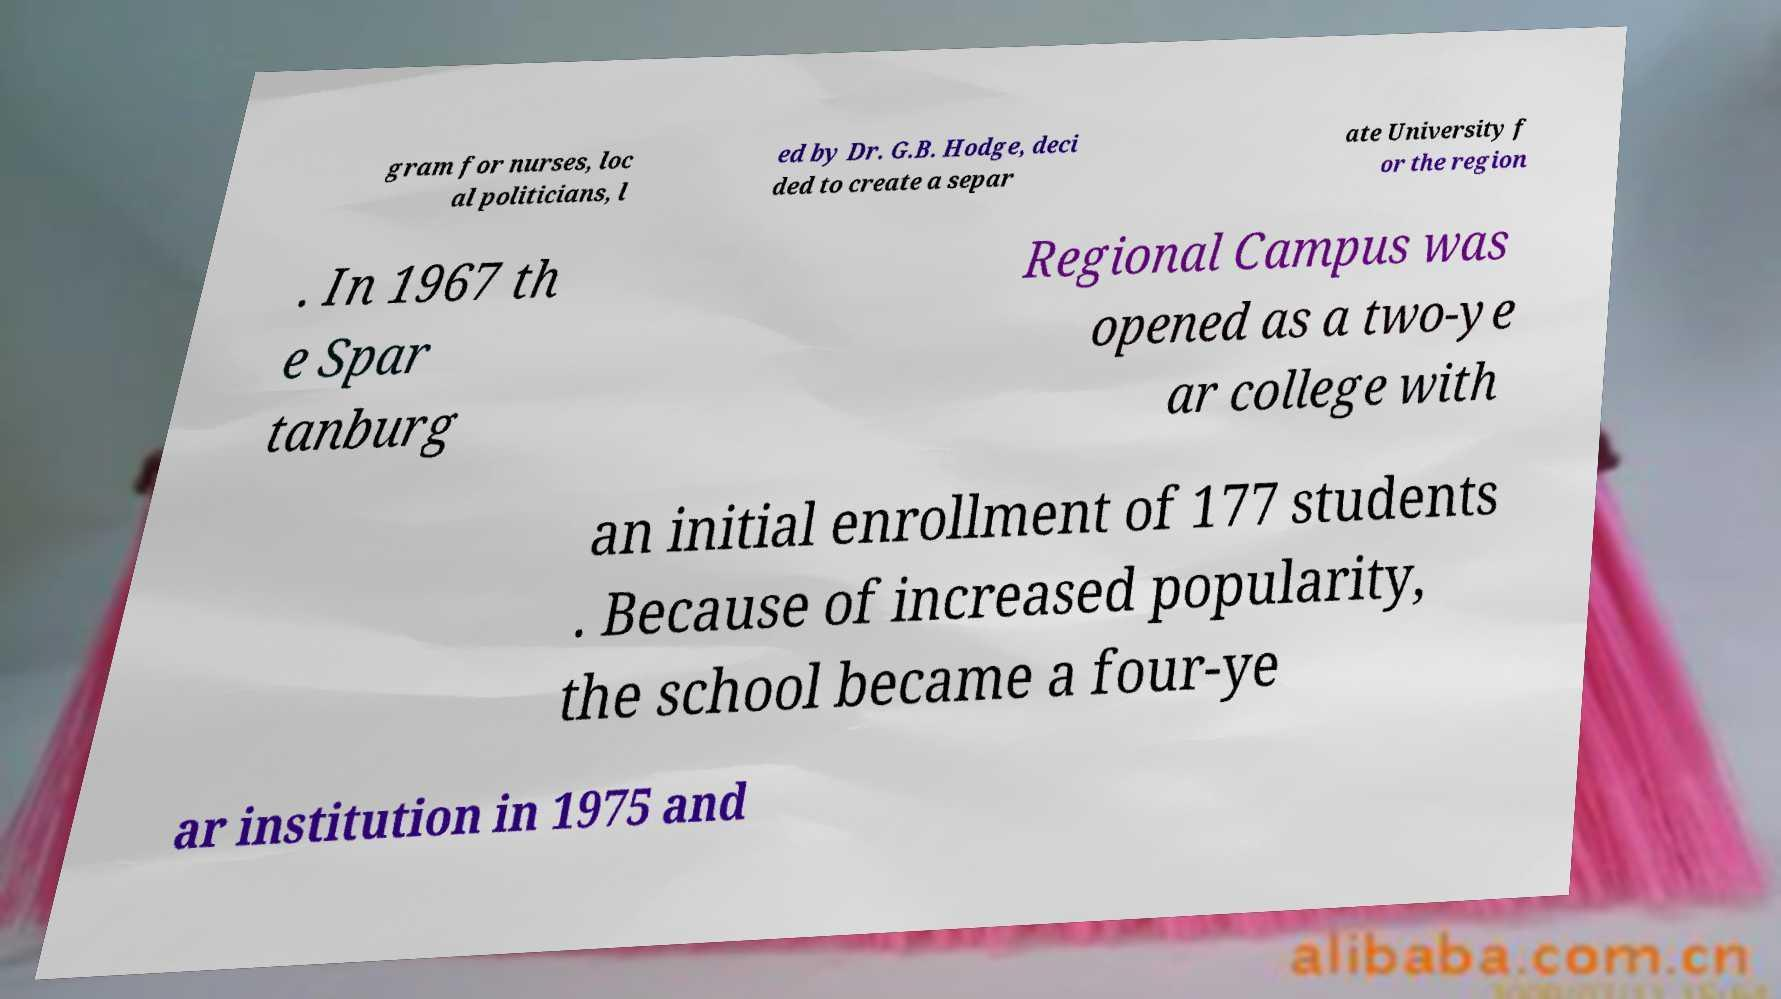What messages or text are displayed in this image? I need them in a readable, typed format. gram for nurses, loc al politicians, l ed by Dr. G.B. Hodge, deci ded to create a separ ate University f or the region . In 1967 th e Spar tanburg Regional Campus was opened as a two-ye ar college with an initial enrollment of 177 students . Because of increased popularity, the school became a four-ye ar institution in 1975 and 